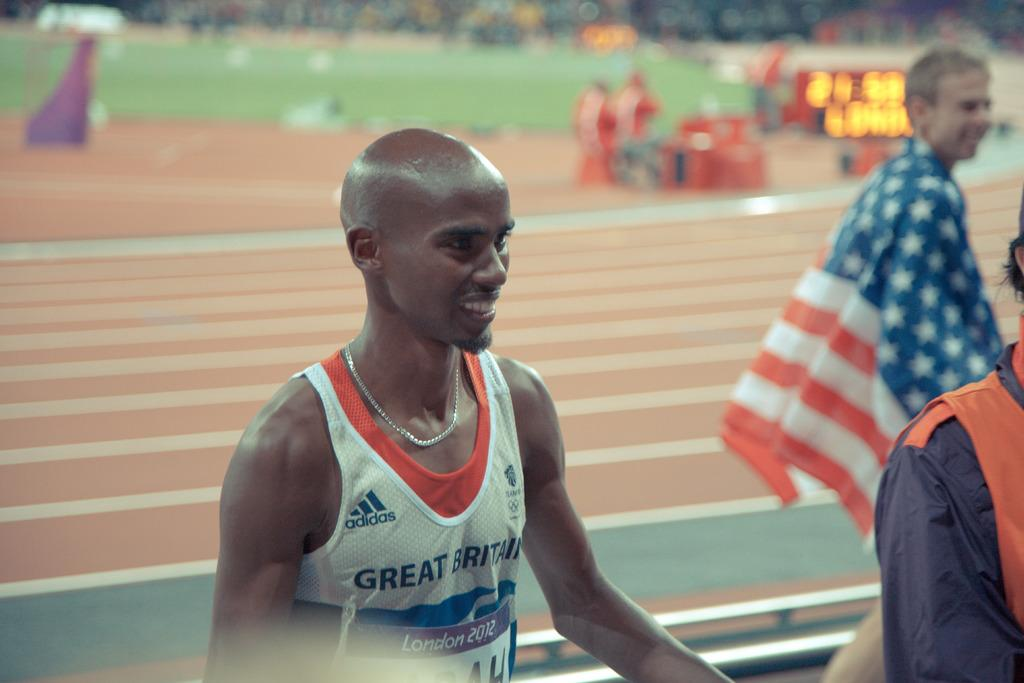<image>
Offer a succinct explanation of the picture presented. A man wearing an Adidas tank top next to a track. 